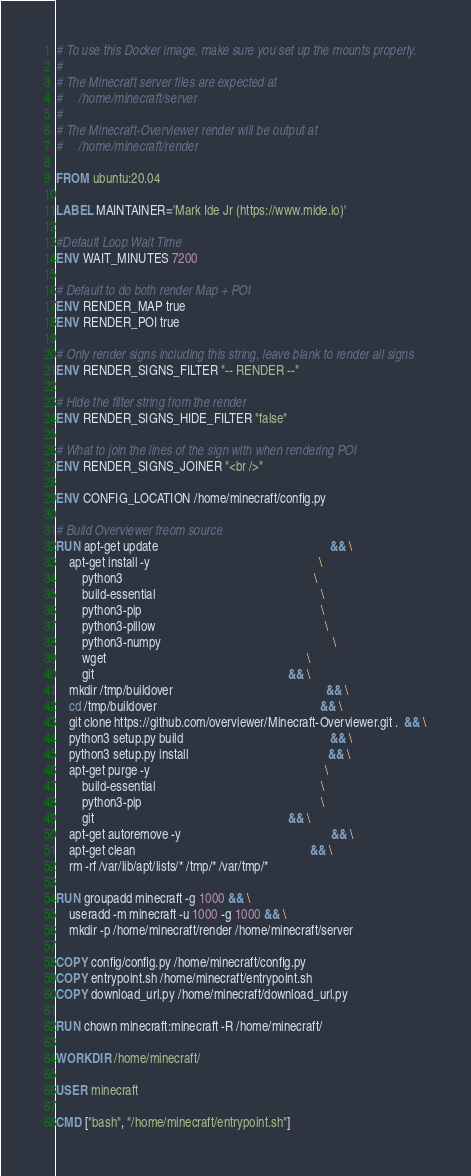<code> <loc_0><loc_0><loc_500><loc_500><_Dockerfile_># To use this Docker image, make sure you set up the mounts properly.
#
# The Minecraft server files are expected at
#     /home/minecraft/server
#
# The Minecraft-Overviewer render will be output at
#     /home/minecraft/render

FROM ubuntu:20.04

LABEL MAINTAINER='Mark Ide Jr (https://www.mide.io)'

#Default Loop Wait Time
ENV WAIT_MINUTES 7200

# Default to do both render Map + POI
ENV RENDER_MAP true
ENV RENDER_POI true

# Only render signs including this string, leave blank to render all signs
ENV RENDER_SIGNS_FILTER "-- RENDER --"

# Hide the filter string from the render
ENV RENDER_SIGNS_HIDE_FILTER "false"

# What to join the lines of the sign with when rendering POI
ENV RENDER_SIGNS_JOINER "<br />"

ENV CONFIG_LOCATION /home/minecraft/config.py

# Build Overviewer freom source
RUN apt-get update                                                      && \
    apt-get install -y                                                     \
        python3                                                            \
        build-essential                                                    \
        python3-pip                                                        \
        python3-pillow                                                     \
        python3-numpy                                                      \
        wget                                                               \
        git                                                             && \
    mkdir /tmp/buildover                                                && \
    cd /tmp/buildover                                                   && \
    git clone https://github.com/overviewer/Minecraft-Overviewer.git .  && \
    python3 setup.py build                                              && \
    python3 setup.py install                                            && \
    apt-get purge -y                                                       \
        build-essential                                                    \
        python3-pip                                                        \
        git                                                             && \
    apt-get autoremove -y                                               && \
    apt-get clean                                                       && \
    rm -rf /var/lib/apt/lists/* /tmp/* /var/tmp/*

RUN groupadd minecraft -g 1000 && \
    useradd -m minecraft -u 1000 -g 1000 && \
    mkdir -p /home/minecraft/render /home/minecraft/server

COPY config/config.py /home/minecraft/config.py
COPY entrypoint.sh /home/minecraft/entrypoint.sh
COPY download_url.py /home/minecraft/download_url.py

RUN chown minecraft:minecraft -R /home/minecraft/

WORKDIR /home/minecraft/

USER minecraft

CMD ["bash", "/home/minecraft/entrypoint.sh"]
</code> 